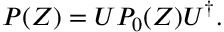Convert formula to latex. <formula><loc_0><loc_0><loc_500><loc_500>P ( Z ) = U P _ { 0 } ( Z ) U ^ { \dag } .</formula> 